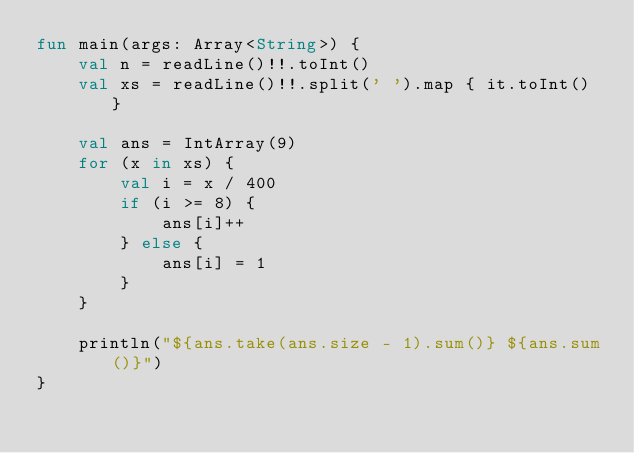<code> <loc_0><loc_0><loc_500><loc_500><_Kotlin_>fun main(args: Array<String>) {
    val n = readLine()!!.toInt()
    val xs = readLine()!!.split(' ').map { it.toInt() }

    val ans = IntArray(9)
    for (x in xs) {
        val i = x / 400
        if (i >= 8) {
            ans[i]++
        } else {
            ans[i] = 1
        }
    }

    println("${ans.take(ans.size - 1).sum()} ${ans.sum()}")
}
</code> 